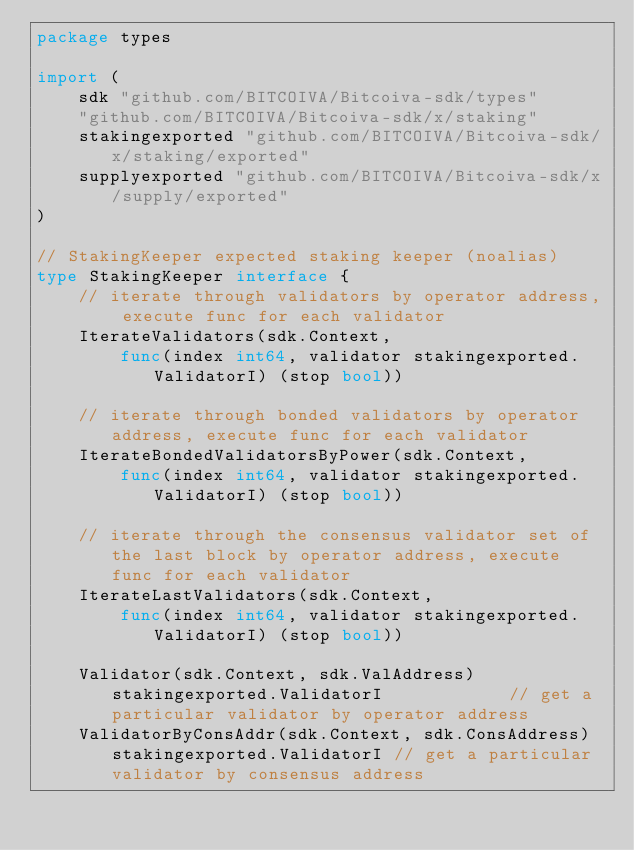<code> <loc_0><loc_0><loc_500><loc_500><_Go_>package types

import (
	sdk "github.com/BITCOIVA/Bitcoiva-sdk/types"
	"github.com/BITCOIVA/Bitcoiva-sdk/x/staking"
	stakingexported "github.com/BITCOIVA/Bitcoiva-sdk/x/staking/exported"
	supplyexported "github.com/BITCOIVA/Bitcoiva-sdk/x/supply/exported"
)

// StakingKeeper expected staking keeper (noalias)
type StakingKeeper interface {
	// iterate through validators by operator address, execute func for each validator
	IterateValidators(sdk.Context,
		func(index int64, validator stakingexported.ValidatorI) (stop bool))

	// iterate through bonded validators by operator address, execute func for each validator
	IterateBondedValidatorsByPower(sdk.Context,
		func(index int64, validator stakingexported.ValidatorI) (stop bool))

	// iterate through the consensus validator set of the last block by operator address, execute func for each validator
	IterateLastValidators(sdk.Context,
		func(index int64, validator stakingexported.ValidatorI) (stop bool))

	Validator(sdk.Context, sdk.ValAddress) stakingexported.ValidatorI            // get a particular validator by operator address
	ValidatorByConsAddr(sdk.Context, sdk.ConsAddress) stakingexported.ValidatorI // get a particular validator by consensus address
</code> 